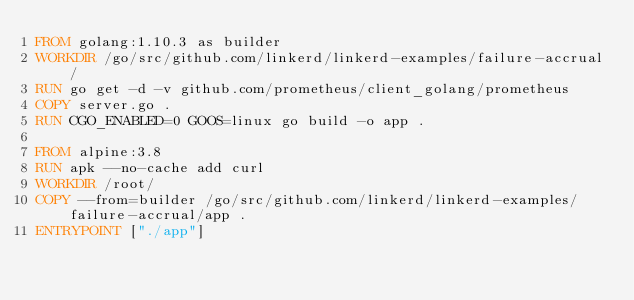<code> <loc_0><loc_0><loc_500><loc_500><_Dockerfile_>FROM golang:1.10.3 as builder
WORKDIR /go/src/github.com/linkerd/linkerd-examples/failure-accrual/
RUN go get -d -v github.com/prometheus/client_golang/prometheus
COPY server.go .
RUN CGO_ENABLED=0 GOOS=linux go build -o app .

FROM alpine:3.8
RUN apk --no-cache add curl
WORKDIR /root/
COPY --from=builder /go/src/github.com/linkerd/linkerd-examples/failure-accrual/app .
ENTRYPOINT ["./app"]
</code> 